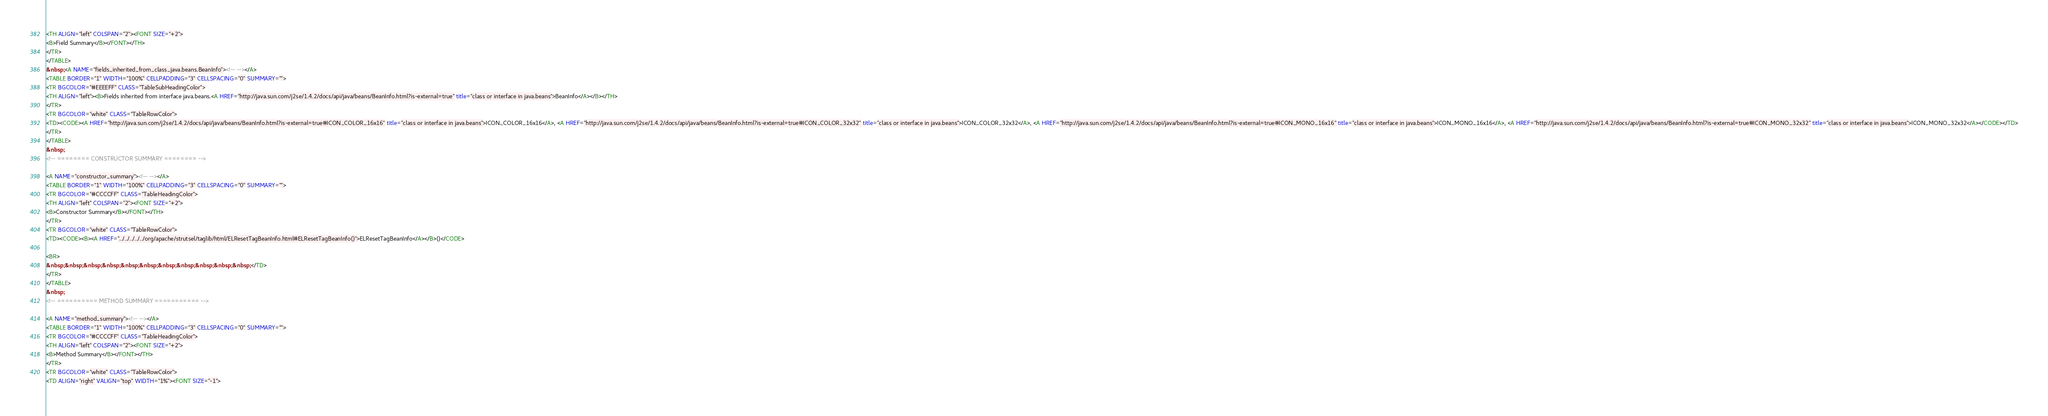Convert code to text. <code><loc_0><loc_0><loc_500><loc_500><_HTML_><TH ALIGN="left" COLSPAN="2"><FONT SIZE="+2">
<B>Field Summary</B></FONT></TH>
</TR>
</TABLE>
&nbsp;<A NAME="fields_inherited_from_class_java.beans.BeanInfo"><!-- --></A>
<TABLE BORDER="1" WIDTH="100%" CELLPADDING="3" CELLSPACING="0" SUMMARY="">
<TR BGCOLOR="#EEEEFF" CLASS="TableSubHeadingColor">
<TH ALIGN="left"><B>Fields inherited from interface java.beans.<A HREF="http://java.sun.com/j2se/1.4.2/docs/api/java/beans/BeanInfo.html?is-external=true" title="class or interface in java.beans">BeanInfo</A></B></TH>
</TR>
<TR BGCOLOR="white" CLASS="TableRowColor">
<TD><CODE><A HREF="http://java.sun.com/j2se/1.4.2/docs/api/java/beans/BeanInfo.html?is-external=true#ICON_COLOR_16x16" title="class or interface in java.beans">ICON_COLOR_16x16</A>, <A HREF="http://java.sun.com/j2se/1.4.2/docs/api/java/beans/BeanInfo.html?is-external=true#ICON_COLOR_32x32" title="class or interface in java.beans">ICON_COLOR_32x32</A>, <A HREF="http://java.sun.com/j2se/1.4.2/docs/api/java/beans/BeanInfo.html?is-external=true#ICON_MONO_16x16" title="class or interface in java.beans">ICON_MONO_16x16</A>, <A HREF="http://java.sun.com/j2se/1.4.2/docs/api/java/beans/BeanInfo.html?is-external=true#ICON_MONO_32x32" title="class or interface in java.beans">ICON_MONO_32x32</A></CODE></TD>
</TR>
</TABLE>
&nbsp;
<!-- ======== CONSTRUCTOR SUMMARY ======== -->

<A NAME="constructor_summary"><!-- --></A>
<TABLE BORDER="1" WIDTH="100%" CELLPADDING="3" CELLSPACING="0" SUMMARY="">
<TR BGCOLOR="#CCCCFF" CLASS="TableHeadingColor">
<TH ALIGN="left" COLSPAN="2"><FONT SIZE="+2">
<B>Constructor Summary</B></FONT></TH>
</TR>
<TR BGCOLOR="white" CLASS="TableRowColor">
<TD><CODE><B><A HREF="../../../../../org/apache/strutsel/taglib/html/ELResetTagBeanInfo.html#ELResetTagBeanInfo()">ELResetTagBeanInfo</A></B>()</CODE>

<BR>
&nbsp;&nbsp;&nbsp;&nbsp;&nbsp;&nbsp;&nbsp;&nbsp;&nbsp;&nbsp;&nbsp;</TD>
</TR>
</TABLE>
&nbsp;
<!-- ========== METHOD SUMMARY =========== -->

<A NAME="method_summary"><!-- --></A>
<TABLE BORDER="1" WIDTH="100%" CELLPADDING="3" CELLSPACING="0" SUMMARY="">
<TR BGCOLOR="#CCCCFF" CLASS="TableHeadingColor">
<TH ALIGN="left" COLSPAN="2"><FONT SIZE="+2">
<B>Method Summary</B></FONT></TH>
</TR>
<TR BGCOLOR="white" CLASS="TableRowColor">
<TD ALIGN="right" VALIGN="top" WIDTH="1%"><FONT SIZE="-1"></code> 